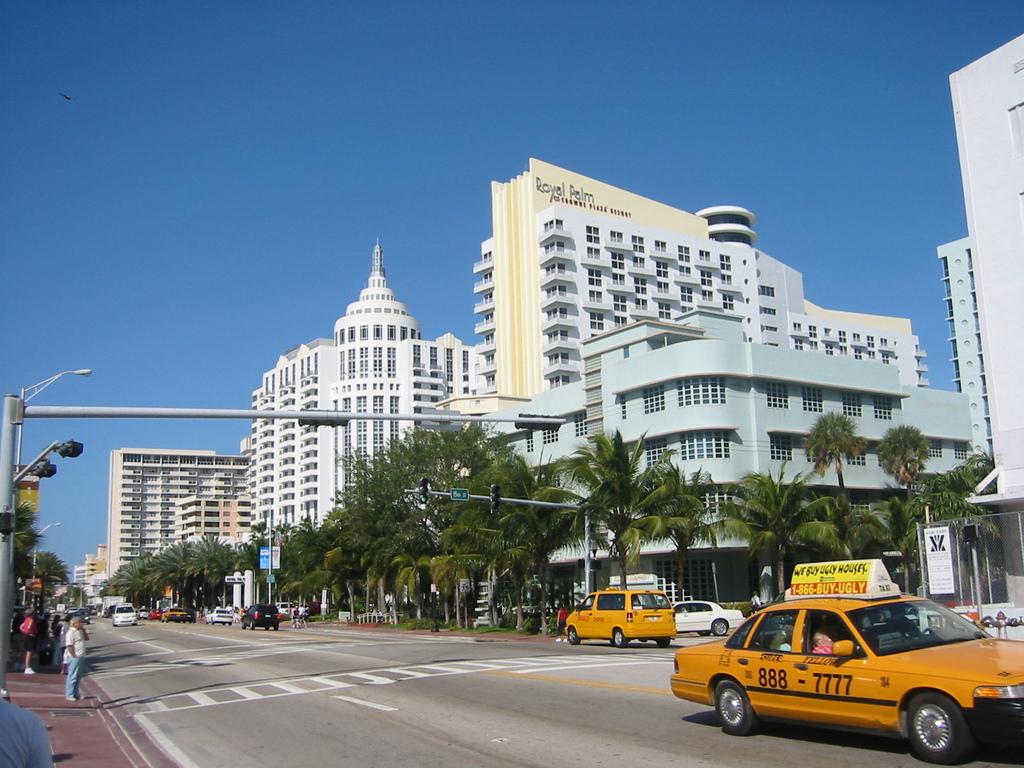What number is on the cab?
Give a very brief answer. 888-7777. What does the sign on top of the cab say they buy?
Offer a very short reply. Ugly. 